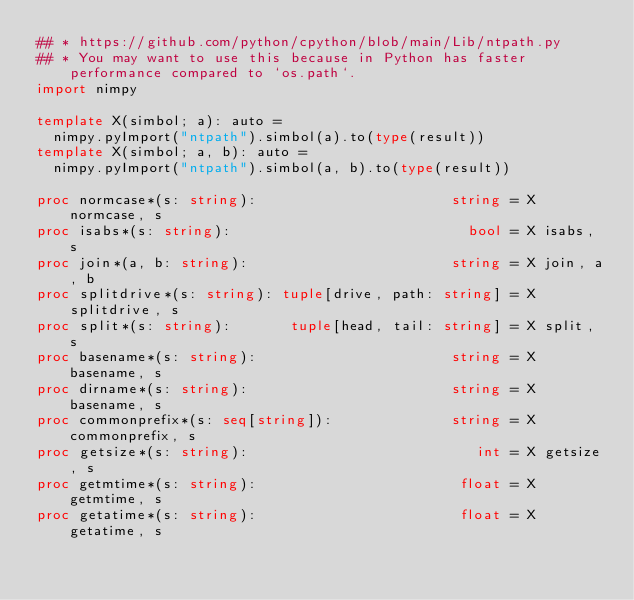Convert code to text. <code><loc_0><loc_0><loc_500><loc_500><_Nim_>## * https://github.com/python/cpython/blob/main/Lib/ntpath.py
## * You may want to use this because in Python has faster performance compared to `os.path`.
import nimpy

template X(simbol; a): auto =
  nimpy.pyImport("ntpath").simbol(a).to(type(result))
template X(simbol; a, b): auto =
  nimpy.pyImport("ntpath").simbol(a, b).to(type(result))

proc normcase*(s: string):                       string = X normcase, s
proc isabs*(s: string):                            bool = X isabs, s
proc join*(a, b: string):                        string = X join, a, b
proc splitdrive*(s: string): tuple[drive, path: string] = X splitdrive, s
proc split*(s: string):       tuple[head, tail: string] = X split, s
proc basename*(s: string):                       string = X basename, s
proc dirname*(s: string):                        string = X basename, s
proc commonprefix*(s: seq[string]):              string = X commonprefix, s
proc getsize*(s: string):                           int = X getsize, s
proc getmtime*(s: string):                        float = X getmtime, s
proc getatime*(s: string):                        float = X getatime, s</code> 